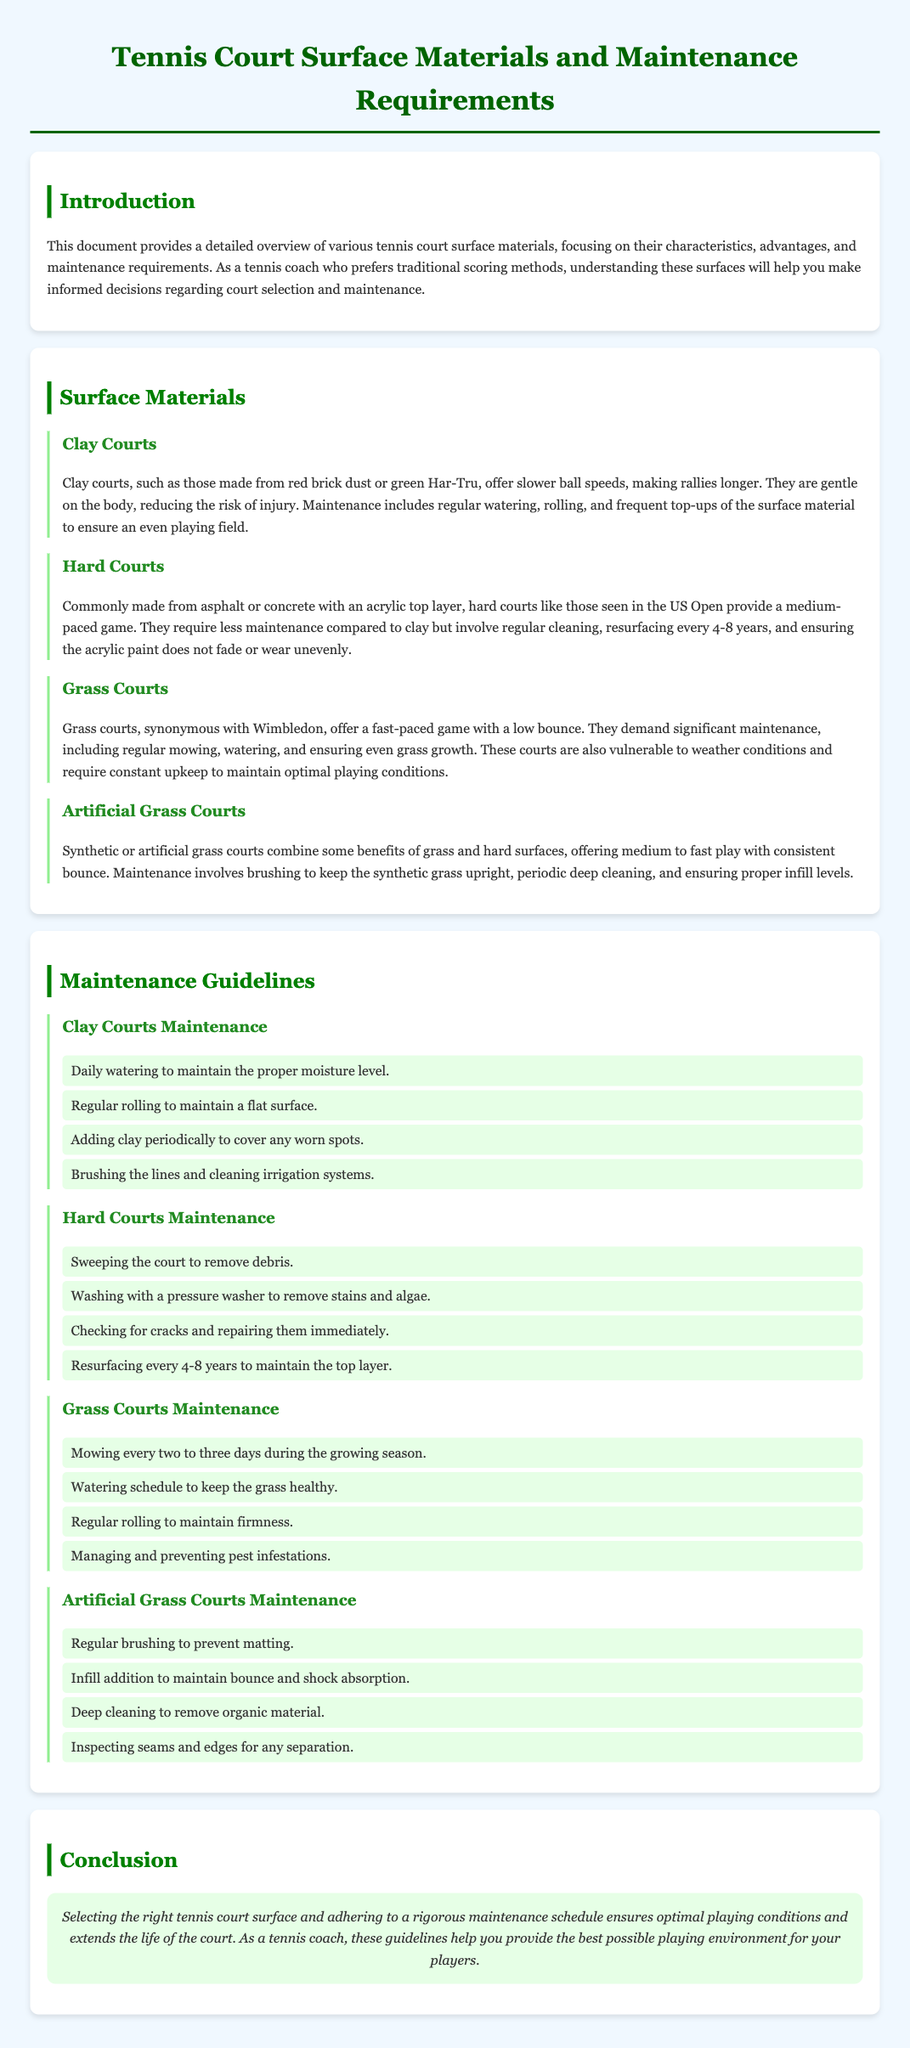What are the four types of tennis court surfaces mentioned? The document lists Clay, Hard, Grass, and Artificial Grass as the four types of tennis court surfaces.
Answer: Clay, Hard, Grass, Artificial Grass What is a key characteristic of clay courts? The document states that clay courts offer slower ball speeds, making rallies longer.
Answer: Slower ball speeds How often should grass courts be mowed during the growing season? The maintenance guidelines specify that grass courts should be mowed every two to three days during the growing season.
Answer: Every two to three days What is the required maintenance for hard courts every 4-8 years? The document indicates that hard courts need resurfacing every 4-8 years.
Answer: Resurfacing What is the maintenance requirement for artificial grass courts regarding brushing? The guidelines mention that regular brushing is required to prevent matting for artificial grass courts.
Answer: Regular brushing Which court surface requires significant maintenance due to weather conditions? The document notes that Grass courts are vulnerable to weather conditions and require constant upkeep.
Answer: Grass courts What is the color associated with the section headers in the document? The section headers feature a green color theme, specifically dark green and medium green shades.
Answer: Green What is the conclusion regarding tennis court surface selection? The document emphasizes that selecting the right tennis court surface ensures optimal playing conditions and extends the life of the court.
Answer: Optimal playing conditions and extended court life 